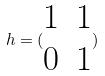<formula> <loc_0><loc_0><loc_500><loc_500>h = ( \begin{matrix} 1 & 1 \\ 0 & 1 \end{matrix} )</formula> 